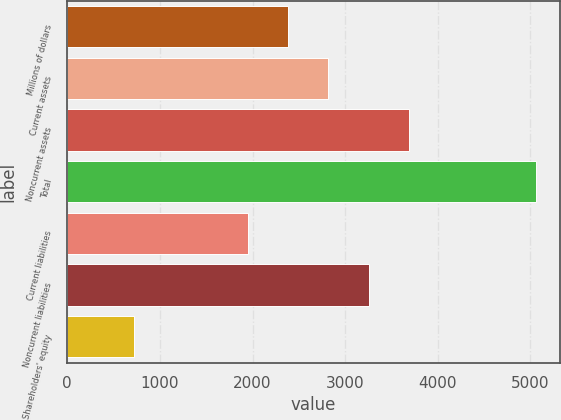Convert chart. <chart><loc_0><loc_0><loc_500><loc_500><bar_chart><fcel>Millions of dollars<fcel>Current assets<fcel>Noncurrent assets<fcel>Total<fcel>Current liabilities<fcel>Noncurrent liabilities<fcel>Shareholders' equity<nl><fcel>2384.4<fcel>2818.8<fcel>3687.6<fcel>5062<fcel>1950<fcel>3253.2<fcel>718<nl></chart> 